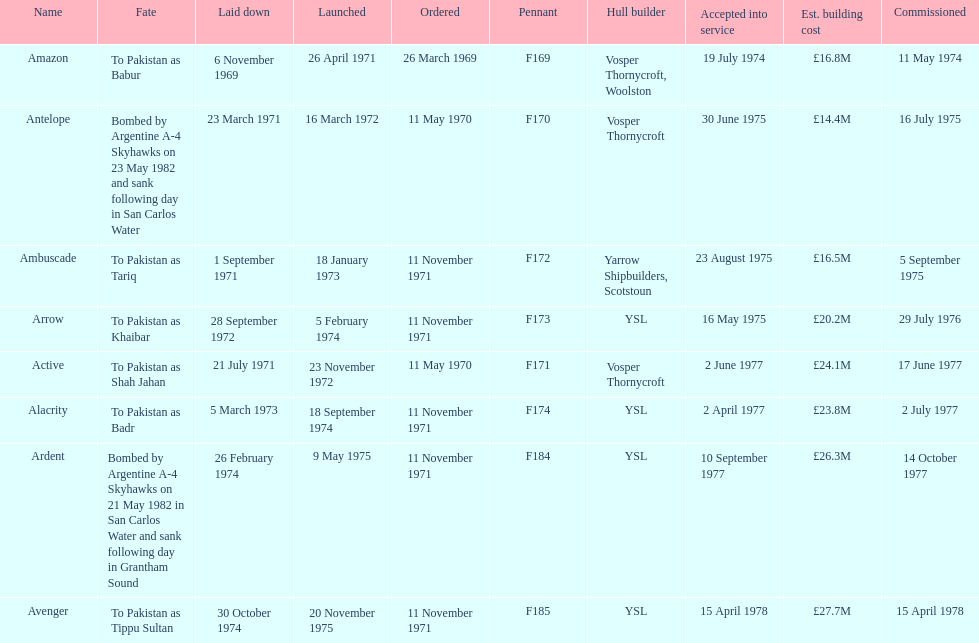How many ships were built after ardent? 1. 